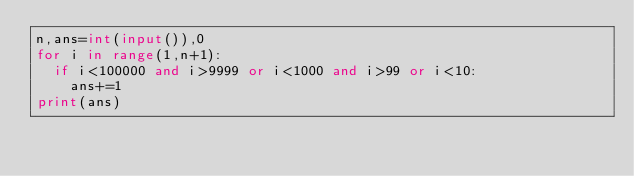<code> <loc_0><loc_0><loc_500><loc_500><_Python_>n,ans=int(input()),0
for i in range(1,n+1):
  if i<100000 and i>9999 or i<1000 and i>99 or i<10:
    ans+=1
print(ans)</code> 